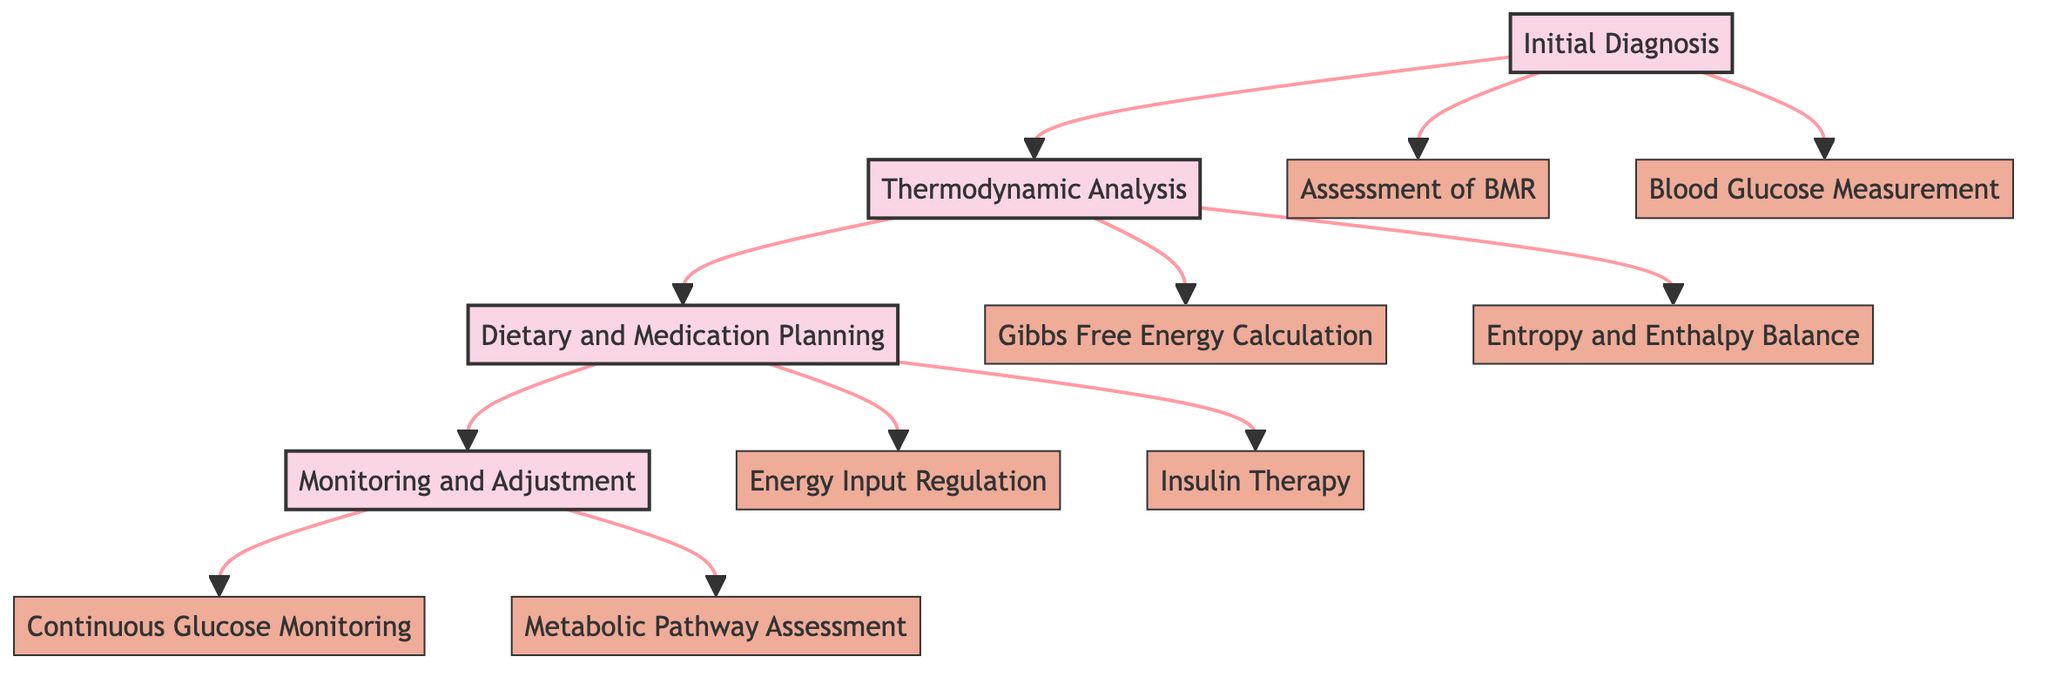What is the first stage of the clinical pathway? The first stage is indicated at the top of the diagram and is labeled as "Initial Diagnosis."
Answer: Initial Diagnosis How many processes are there in the "Dietary and Medication Planning" stage? The diagram shows two processes connected to the "Dietary and Medication Planning" stage, which are "Energy Input Regulation" and "Insulin Therapy."
Answer: 2 What process directly follows the "Thermodynamic Analysis" stage? The diagram indicates a direct flow from "Thermodynamic Analysis" to "Dietary and Medication Planning," showing the sequence of stages.
Answer: Dietary and Medication Planning Which two processes are part of the "Monitoring and Adjustment" stage? The processes listed under the "Monitoring and Adjustment" stage are "Continuous Glucose Monitoring" and "Metabolic Pathway Assessment."
Answer: Continuous Glucose Monitoring, Metabolic Pathway Assessment What type of analysis is conducted between the "Initial Diagnosis" and "Dietary and Medication Planning" stages? The flow between these two stages involves "Thermodynamic Analysis," which is focused on evaluating metabolic reactions.
Answer: Thermodynamic Analysis What analysis is performed to evaluate metabolic reactions? The relevant process listed under the "Thermodynamic Analysis" stage for this evaluation is "Gibbs Free Energy Calculation" and "Entropy and Enthalpy Balance."
Answer: Gibbs Free Energy Calculation, Entropy and Enthalpy Balance What is the purpose of the "Assessment of Basal Metabolic Rate (BMR)"? This process is aimed at calculating the energy expenditure of the patient based on thermodynamic principles as part of the diagnosis.
Answer: Calculate the energy expenditure Which stage includes the process of "Insulin Therapy"? "Insulin Therapy" is a part of the "Dietary and Medication Planning" stage, focusing on medication to support metabolic balance.
Answer: Dietary and Medication Planning What is the significance of "Continuous Glucose Monitoring (CGM)" in the pathway? This process is vital for regularly measuring glucose levels to observe thermodynamic consistency during diabetes management.
Answer: Observe thermodynamic consistency 